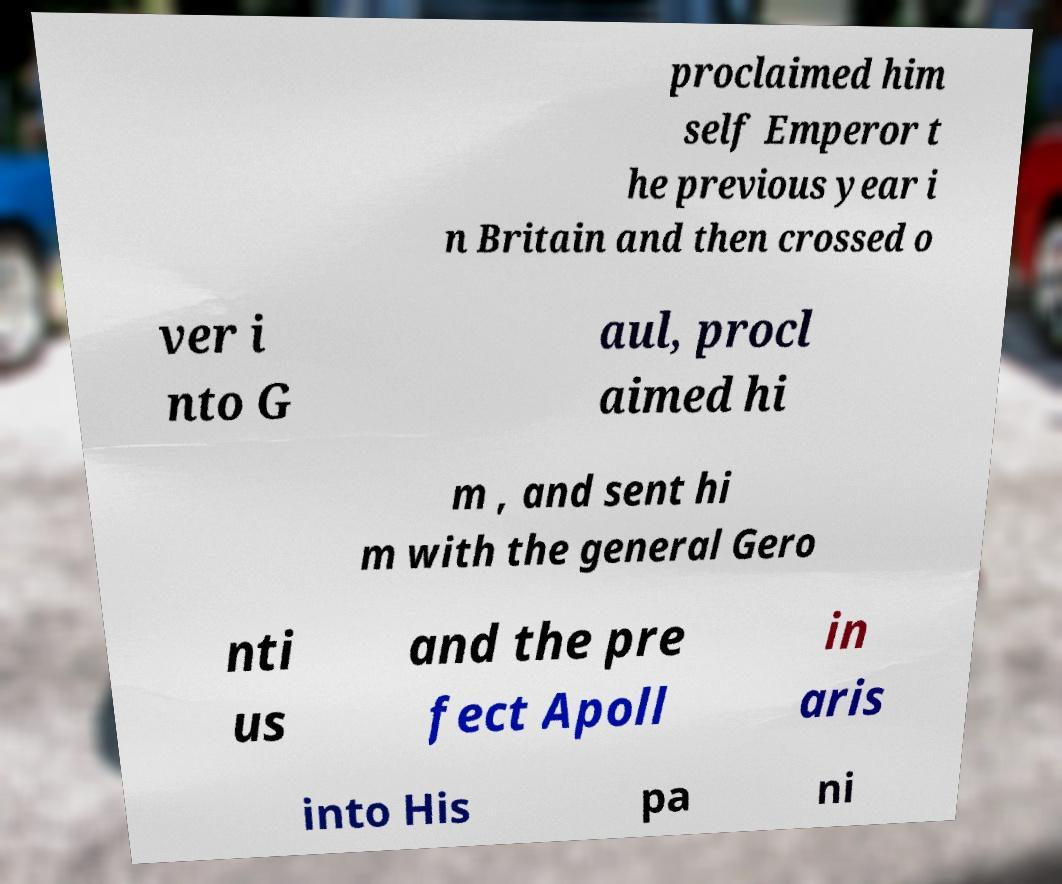I need the written content from this picture converted into text. Can you do that? proclaimed him self Emperor t he previous year i n Britain and then crossed o ver i nto G aul, procl aimed hi m , and sent hi m with the general Gero nti us and the pre fect Apoll in aris into His pa ni 